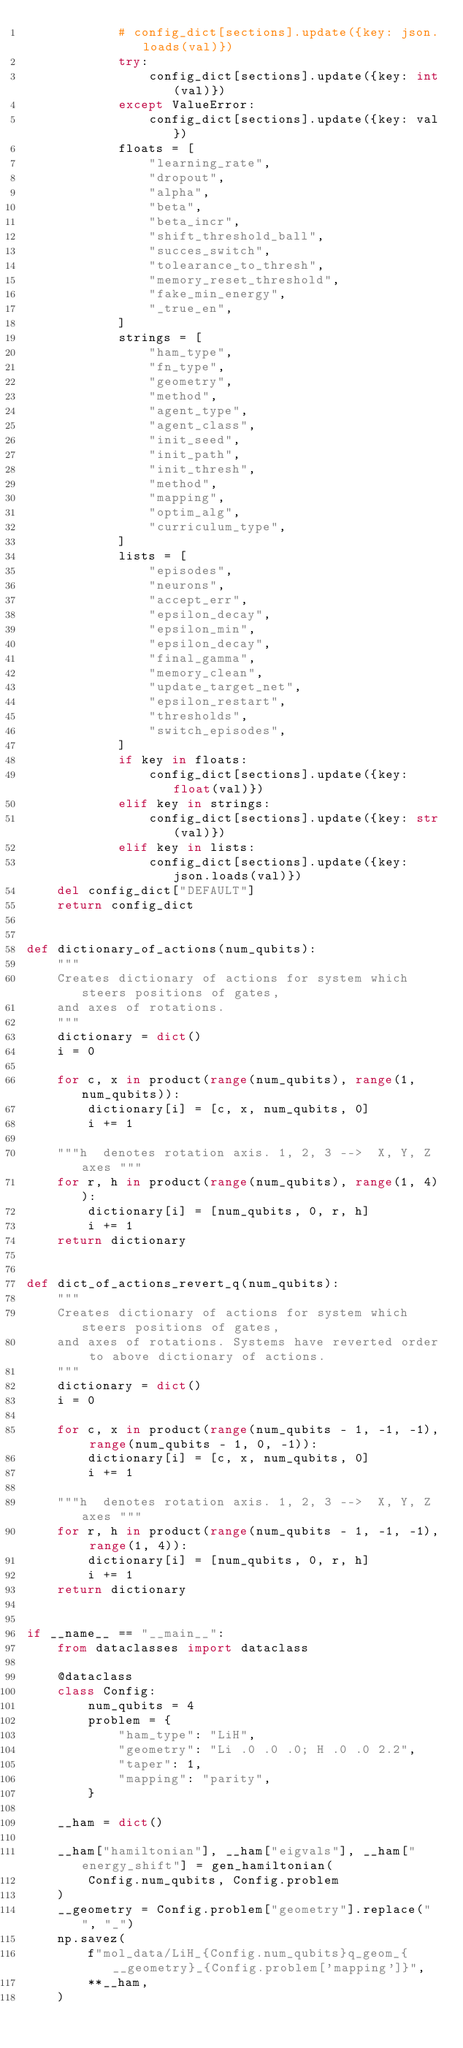Convert code to text. <code><loc_0><loc_0><loc_500><loc_500><_Python_>            # config_dict[sections].update({key: json.loads(val)})
            try:
                config_dict[sections].update({key: int(val)})
            except ValueError:
                config_dict[sections].update({key: val})
            floats = [
                "learning_rate",
                "dropout",
                "alpha",
                "beta",
                "beta_incr",
                "shift_threshold_ball",
                "succes_switch",
                "tolearance_to_thresh",
                "memory_reset_threshold",
                "fake_min_energy",
                "_true_en",
            ]
            strings = [
                "ham_type",
                "fn_type",
                "geometry",
                "method",
                "agent_type",
                "agent_class",
                "init_seed",
                "init_path",
                "init_thresh",
                "method",
                "mapping",
                "optim_alg",
                "curriculum_type",
            ]
            lists = [
                "episodes",
                "neurons",
                "accept_err",
                "epsilon_decay",
                "epsilon_min",
                "epsilon_decay",
                "final_gamma",
                "memory_clean",
                "update_target_net",
                "epsilon_restart",
                "thresholds",
                "switch_episodes",
            ]
            if key in floats:
                config_dict[sections].update({key: float(val)})
            elif key in strings:
                config_dict[sections].update({key: str(val)})
            elif key in lists:
                config_dict[sections].update({key: json.loads(val)})
    del config_dict["DEFAULT"]
    return config_dict


def dictionary_of_actions(num_qubits):
    """
    Creates dictionary of actions for system which steers positions of gates,
    and axes of rotations.
    """
    dictionary = dict()
    i = 0

    for c, x in product(range(num_qubits), range(1, num_qubits)):
        dictionary[i] = [c, x, num_qubits, 0]
        i += 1

    """h  denotes rotation axis. 1, 2, 3 -->  X, Y, Z axes """
    for r, h in product(range(num_qubits), range(1, 4)):
        dictionary[i] = [num_qubits, 0, r, h]
        i += 1
    return dictionary


def dict_of_actions_revert_q(num_qubits):
    """
    Creates dictionary of actions for system which steers positions of gates,
    and axes of rotations. Systems have reverted order to above dictionary of actions.
    """
    dictionary = dict()
    i = 0

    for c, x in product(range(num_qubits - 1, -1, -1), range(num_qubits - 1, 0, -1)):
        dictionary[i] = [c, x, num_qubits, 0]
        i += 1

    """h  denotes rotation axis. 1, 2, 3 -->  X, Y, Z axes """
    for r, h in product(range(num_qubits - 1, -1, -1), range(1, 4)):
        dictionary[i] = [num_qubits, 0, r, h]
        i += 1
    return dictionary


if __name__ == "__main__":
    from dataclasses import dataclass

    @dataclass
    class Config:
        num_qubits = 4
        problem = {
            "ham_type": "LiH",
            "geometry": "Li .0 .0 .0; H .0 .0 2.2",
            "taper": 1,
            "mapping": "parity",
        }

    __ham = dict()

    __ham["hamiltonian"], __ham["eigvals"], __ham["energy_shift"] = gen_hamiltonian(
        Config.num_qubits, Config.problem
    )
    __geometry = Config.problem["geometry"].replace(" ", "_")
    np.savez(
        f"mol_data/LiH_{Config.num_qubits}q_geom_{__geometry}_{Config.problem['mapping']}",
        **__ham,
    )
</code> 